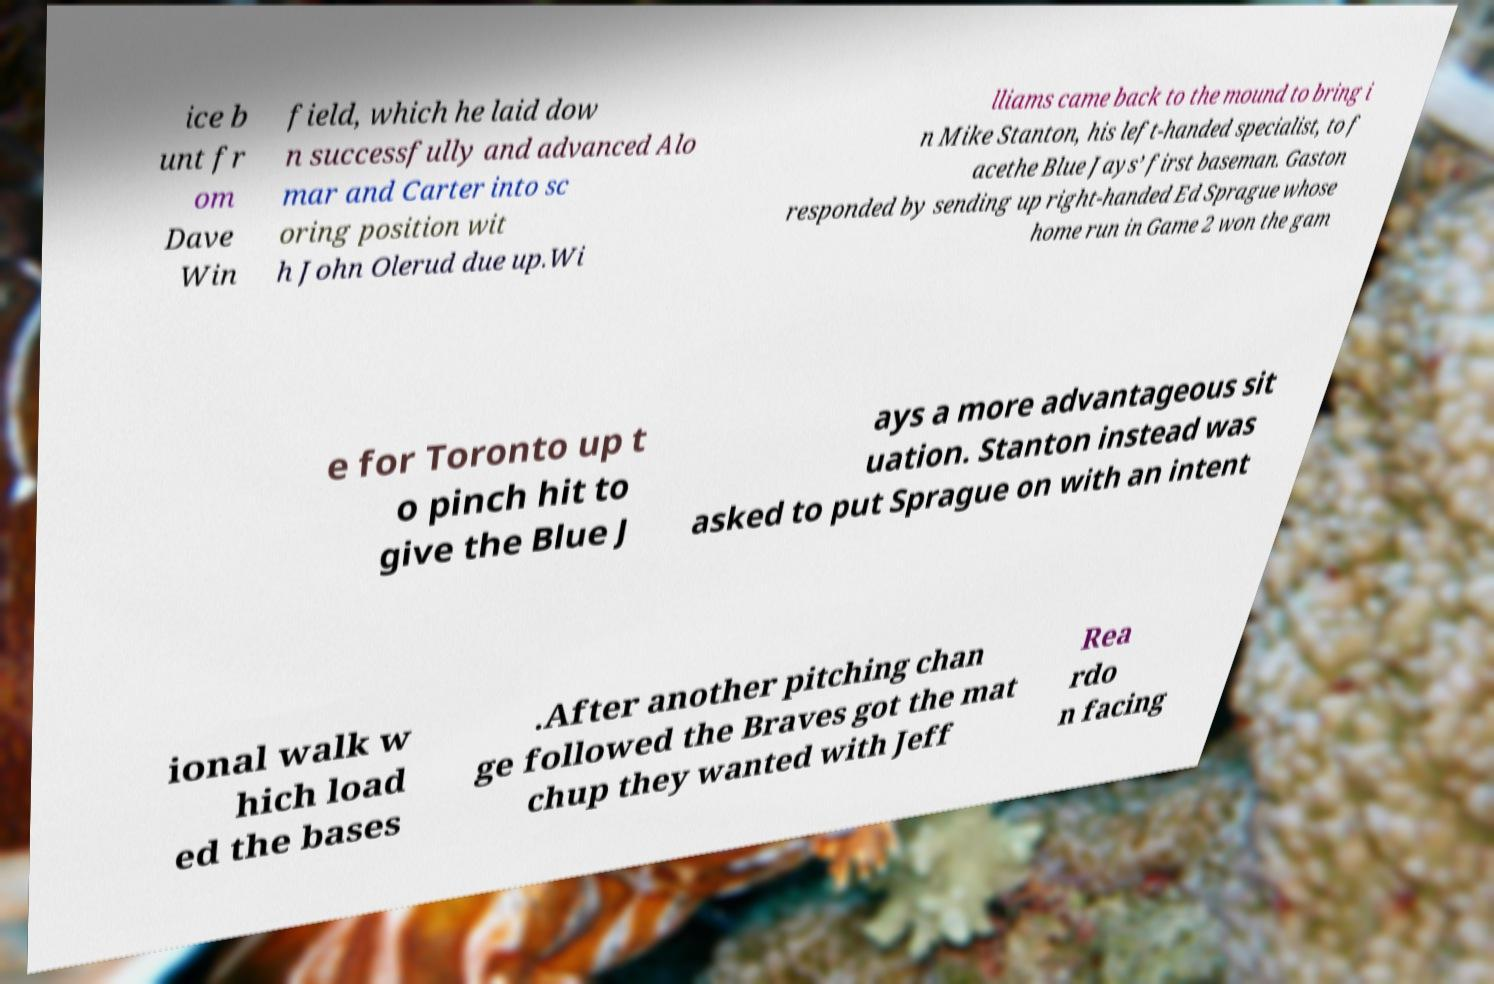Could you assist in decoding the text presented in this image and type it out clearly? ice b unt fr om Dave Win field, which he laid dow n successfully and advanced Alo mar and Carter into sc oring position wit h John Olerud due up.Wi lliams came back to the mound to bring i n Mike Stanton, his left-handed specialist, to f acethe Blue Jays’ first baseman. Gaston responded by sending up right-handed Ed Sprague whose home run in Game 2 won the gam e for Toronto up t o pinch hit to give the Blue J ays a more advantageous sit uation. Stanton instead was asked to put Sprague on with an intent ional walk w hich load ed the bases .After another pitching chan ge followed the Braves got the mat chup they wanted with Jeff Rea rdo n facing 